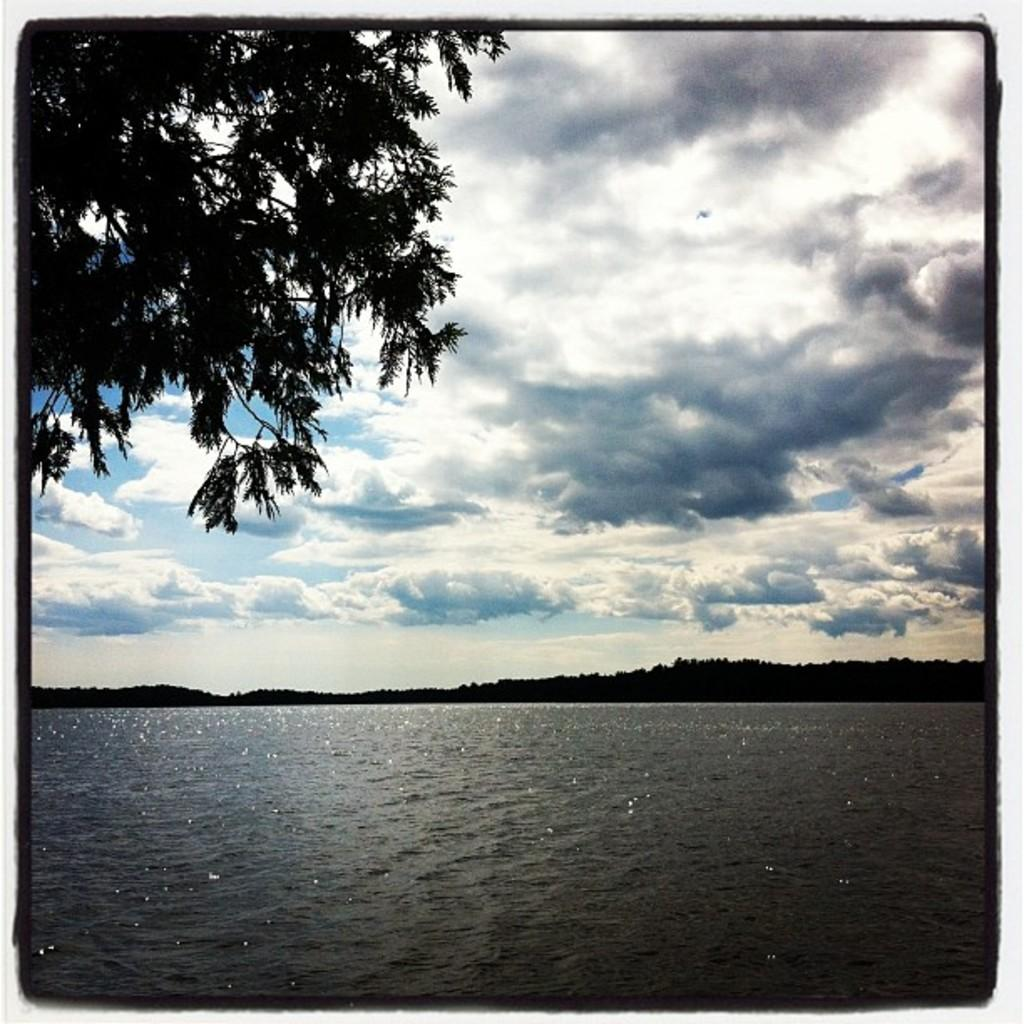What can be seen in the sky in the image? The sky with clouds is visible in the image. What is located at the bottom of the image? There is water at the bottom of the image. What type of vegetation is present in the background of the image? Greenery is present in the background of the image. Where is the tree located in the image? There is a tree in the top left of the image. What type of unit is conducting business in the image? There is no unit or business present in the image; it features natural elements such as sky, water, greenery, and a tree. What mathematical operation is being performed on the clouds in the image? There is no mathematical operation being performed on the clouds in the image; they are simply visible in the sky. 